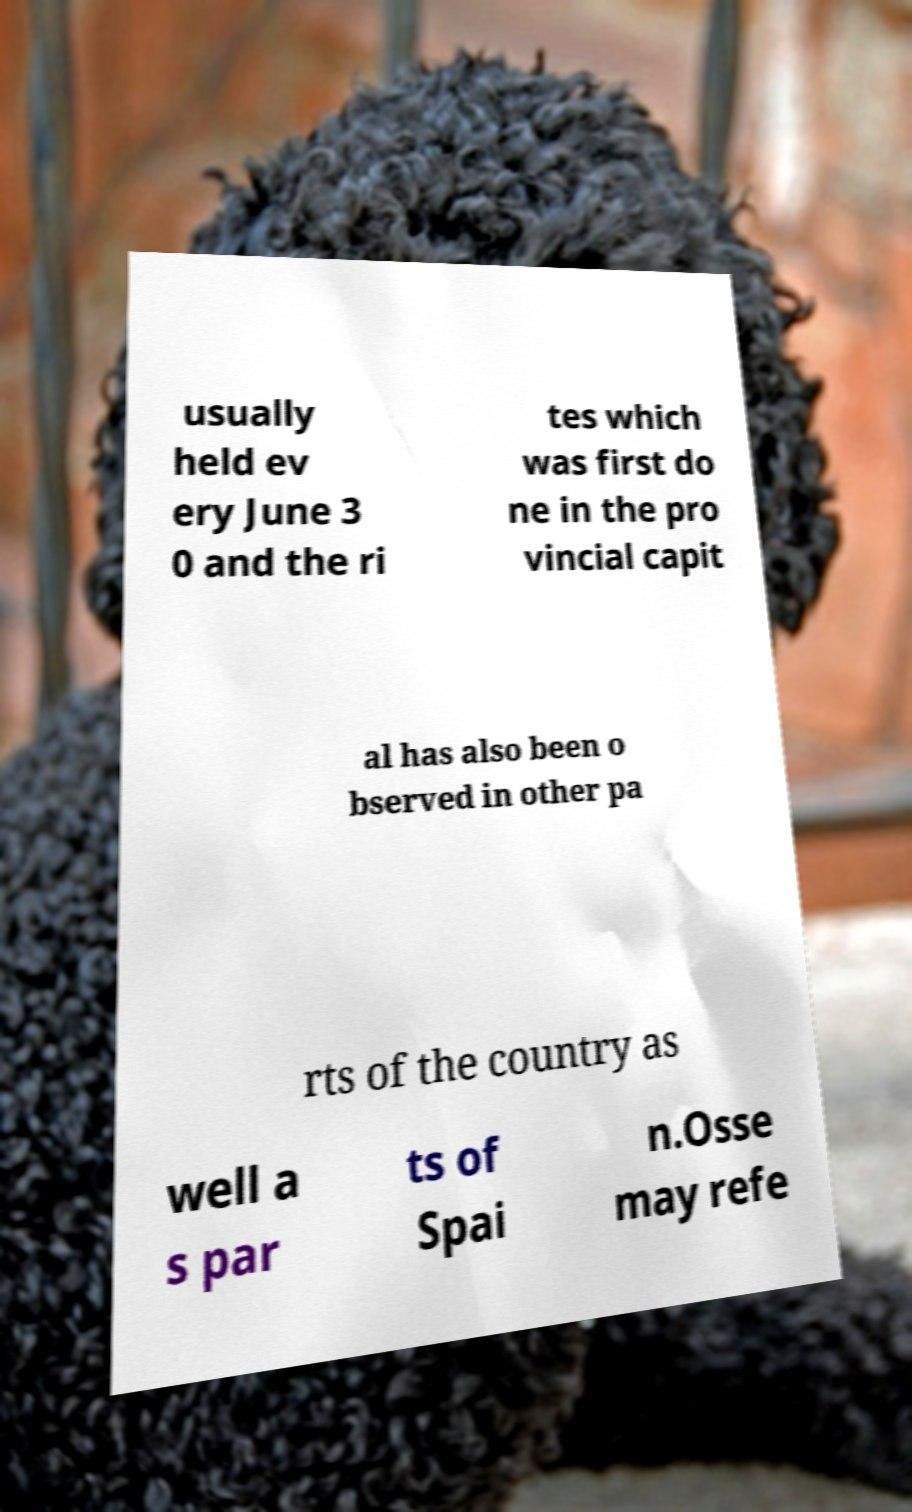Can you accurately transcribe the text from the provided image for me? usually held ev ery June 3 0 and the ri tes which was first do ne in the pro vincial capit al has also been o bserved in other pa rts of the country as well a s par ts of Spai n.Osse may refe 